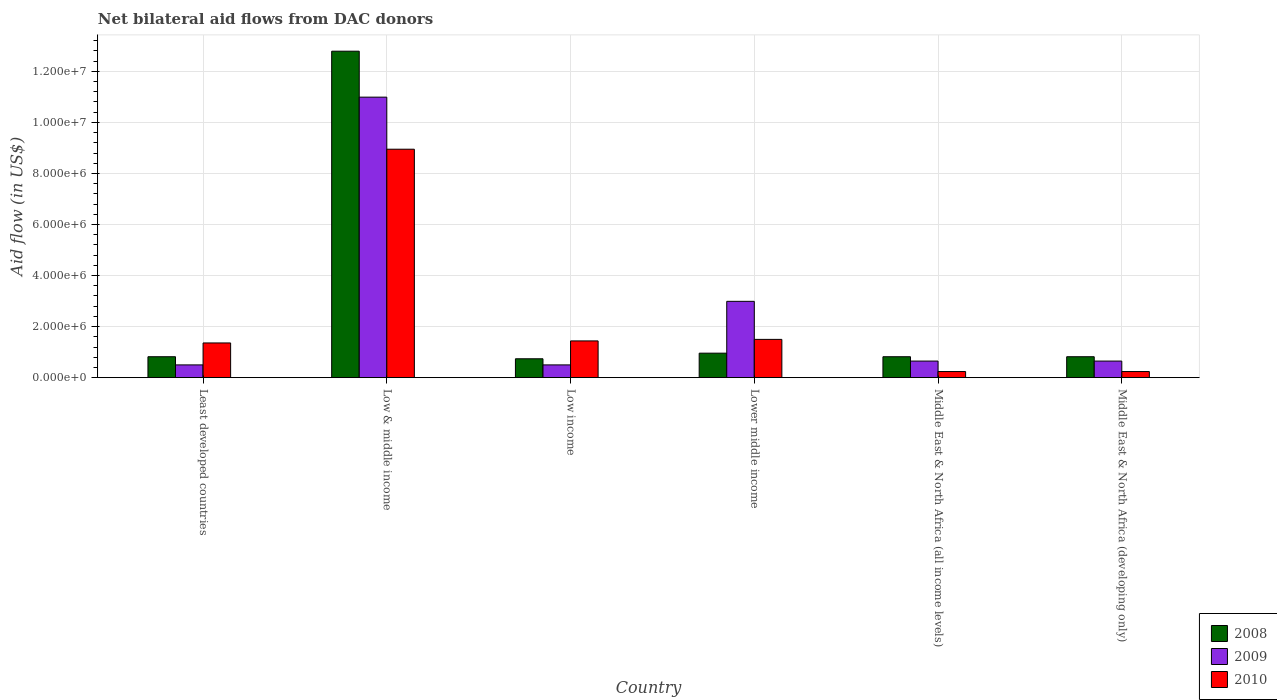How many different coloured bars are there?
Your answer should be compact. 3. How many bars are there on the 5th tick from the left?
Offer a terse response. 3. How many bars are there on the 1st tick from the right?
Your answer should be very brief. 3. What is the label of the 4th group of bars from the left?
Make the answer very short. Lower middle income. What is the net bilateral aid flow in 2008 in Lower middle income?
Provide a succinct answer. 9.60e+05. Across all countries, what is the maximum net bilateral aid flow in 2009?
Give a very brief answer. 1.10e+07. Across all countries, what is the minimum net bilateral aid flow in 2009?
Provide a short and direct response. 5.00e+05. In which country was the net bilateral aid flow in 2010 minimum?
Your response must be concise. Middle East & North Africa (all income levels). What is the total net bilateral aid flow in 2009 in the graph?
Your answer should be compact. 1.63e+07. What is the difference between the net bilateral aid flow in 2010 in Least developed countries and that in Middle East & North Africa (all income levels)?
Ensure brevity in your answer.  1.12e+06. What is the difference between the net bilateral aid flow in 2010 in Low & middle income and the net bilateral aid flow in 2009 in Least developed countries?
Offer a terse response. 8.45e+06. What is the average net bilateral aid flow in 2009 per country?
Ensure brevity in your answer.  2.71e+06. What is the difference between the net bilateral aid flow of/in 2010 and net bilateral aid flow of/in 2008 in Low income?
Give a very brief answer. 7.00e+05. Is the net bilateral aid flow in 2008 in Least developed countries less than that in Middle East & North Africa (all income levels)?
Your answer should be very brief. No. Is the difference between the net bilateral aid flow in 2010 in Least developed countries and Middle East & North Africa (developing only) greater than the difference between the net bilateral aid flow in 2008 in Least developed countries and Middle East & North Africa (developing only)?
Keep it short and to the point. Yes. What is the difference between the highest and the second highest net bilateral aid flow in 2010?
Keep it short and to the point. 7.51e+06. What is the difference between the highest and the lowest net bilateral aid flow in 2008?
Ensure brevity in your answer.  1.20e+07. In how many countries, is the net bilateral aid flow in 2008 greater than the average net bilateral aid flow in 2008 taken over all countries?
Keep it short and to the point. 1. Is the sum of the net bilateral aid flow in 2010 in Lower middle income and Middle East & North Africa (all income levels) greater than the maximum net bilateral aid flow in 2009 across all countries?
Provide a succinct answer. No. What does the 1st bar from the left in Low & middle income represents?
Provide a short and direct response. 2008. How many countries are there in the graph?
Provide a succinct answer. 6. What is the difference between two consecutive major ticks on the Y-axis?
Provide a short and direct response. 2.00e+06. Does the graph contain any zero values?
Keep it short and to the point. No. Where does the legend appear in the graph?
Provide a succinct answer. Bottom right. How are the legend labels stacked?
Your answer should be very brief. Vertical. What is the title of the graph?
Make the answer very short. Net bilateral aid flows from DAC donors. Does "1991" appear as one of the legend labels in the graph?
Make the answer very short. No. What is the label or title of the X-axis?
Provide a short and direct response. Country. What is the label or title of the Y-axis?
Provide a short and direct response. Aid flow (in US$). What is the Aid flow (in US$) of 2008 in Least developed countries?
Ensure brevity in your answer.  8.20e+05. What is the Aid flow (in US$) of 2009 in Least developed countries?
Ensure brevity in your answer.  5.00e+05. What is the Aid flow (in US$) in 2010 in Least developed countries?
Offer a very short reply. 1.36e+06. What is the Aid flow (in US$) of 2008 in Low & middle income?
Make the answer very short. 1.28e+07. What is the Aid flow (in US$) of 2009 in Low & middle income?
Your answer should be very brief. 1.10e+07. What is the Aid flow (in US$) of 2010 in Low & middle income?
Provide a succinct answer. 8.95e+06. What is the Aid flow (in US$) in 2008 in Low income?
Offer a terse response. 7.40e+05. What is the Aid flow (in US$) in 2010 in Low income?
Make the answer very short. 1.44e+06. What is the Aid flow (in US$) of 2008 in Lower middle income?
Your answer should be very brief. 9.60e+05. What is the Aid flow (in US$) in 2009 in Lower middle income?
Provide a succinct answer. 2.99e+06. What is the Aid flow (in US$) of 2010 in Lower middle income?
Offer a terse response. 1.50e+06. What is the Aid flow (in US$) of 2008 in Middle East & North Africa (all income levels)?
Provide a succinct answer. 8.20e+05. What is the Aid flow (in US$) of 2009 in Middle East & North Africa (all income levels)?
Provide a succinct answer. 6.50e+05. What is the Aid flow (in US$) in 2008 in Middle East & North Africa (developing only)?
Give a very brief answer. 8.20e+05. What is the Aid flow (in US$) of 2009 in Middle East & North Africa (developing only)?
Ensure brevity in your answer.  6.50e+05. What is the Aid flow (in US$) of 2010 in Middle East & North Africa (developing only)?
Offer a terse response. 2.40e+05. Across all countries, what is the maximum Aid flow (in US$) in 2008?
Give a very brief answer. 1.28e+07. Across all countries, what is the maximum Aid flow (in US$) of 2009?
Offer a terse response. 1.10e+07. Across all countries, what is the maximum Aid flow (in US$) in 2010?
Ensure brevity in your answer.  8.95e+06. Across all countries, what is the minimum Aid flow (in US$) of 2008?
Provide a short and direct response. 7.40e+05. Across all countries, what is the minimum Aid flow (in US$) of 2009?
Ensure brevity in your answer.  5.00e+05. Across all countries, what is the minimum Aid flow (in US$) in 2010?
Provide a short and direct response. 2.40e+05. What is the total Aid flow (in US$) in 2008 in the graph?
Offer a very short reply. 1.70e+07. What is the total Aid flow (in US$) in 2009 in the graph?
Keep it short and to the point. 1.63e+07. What is the total Aid flow (in US$) of 2010 in the graph?
Your answer should be very brief. 1.37e+07. What is the difference between the Aid flow (in US$) in 2008 in Least developed countries and that in Low & middle income?
Your answer should be very brief. -1.20e+07. What is the difference between the Aid flow (in US$) in 2009 in Least developed countries and that in Low & middle income?
Your answer should be very brief. -1.05e+07. What is the difference between the Aid flow (in US$) of 2010 in Least developed countries and that in Low & middle income?
Your answer should be compact. -7.59e+06. What is the difference between the Aid flow (in US$) in 2008 in Least developed countries and that in Low income?
Ensure brevity in your answer.  8.00e+04. What is the difference between the Aid flow (in US$) in 2010 in Least developed countries and that in Low income?
Offer a very short reply. -8.00e+04. What is the difference between the Aid flow (in US$) in 2009 in Least developed countries and that in Lower middle income?
Offer a very short reply. -2.49e+06. What is the difference between the Aid flow (in US$) of 2010 in Least developed countries and that in Lower middle income?
Offer a very short reply. -1.40e+05. What is the difference between the Aid flow (in US$) of 2009 in Least developed countries and that in Middle East & North Africa (all income levels)?
Provide a succinct answer. -1.50e+05. What is the difference between the Aid flow (in US$) in 2010 in Least developed countries and that in Middle East & North Africa (all income levels)?
Your answer should be very brief. 1.12e+06. What is the difference between the Aid flow (in US$) of 2009 in Least developed countries and that in Middle East & North Africa (developing only)?
Offer a very short reply. -1.50e+05. What is the difference between the Aid flow (in US$) of 2010 in Least developed countries and that in Middle East & North Africa (developing only)?
Offer a very short reply. 1.12e+06. What is the difference between the Aid flow (in US$) of 2008 in Low & middle income and that in Low income?
Offer a very short reply. 1.20e+07. What is the difference between the Aid flow (in US$) in 2009 in Low & middle income and that in Low income?
Your answer should be compact. 1.05e+07. What is the difference between the Aid flow (in US$) in 2010 in Low & middle income and that in Low income?
Make the answer very short. 7.51e+06. What is the difference between the Aid flow (in US$) in 2008 in Low & middle income and that in Lower middle income?
Provide a succinct answer. 1.18e+07. What is the difference between the Aid flow (in US$) of 2009 in Low & middle income and that in Lower middle income?
Make the answer very short. 8.00e+06. What is the difference between the Aid flow (in US$) of 2010 in Low & middle income and that in Lower middle income?
Your answer should be compact. 7.45e+06. What is the difference between the Aid flow (in US$) in 2008 in Low & middle income and that in Middle East & North Africa (all income levels)?
Offer a very short reply. 1.20e+07. What is the difference between the Aid flow (in US$) of 2009 in Low & middle income and that in Middle East & North Africa (all income levels)?
Your answer should be compact. 1.03e+07. What is the difference between the Aid flow (in US$) of 2010 in Low & middle income and that in Middle East & North Africa (all income levels)?
Provide a succinct answer. 8.71e+06. What is the difference between the Aid flow (in US$) in 2008 in Low & middle income and that in Middle East & North Africa (developing only)?
Your answer should be very brief. 1.20e+07. What is the difference between the Aid flow (in US$) of 2009 in Low & middle income and that in Middle East & North Africa (developing only)?
Offer a very short reply. 1.03e+07. What is the difference between the Aid flow (in US$) in 2010 in Low & middle income and that in Middle East & North Africa (developing only)?
Make the answer very short. 8.71e+06. What is the difference between the Aid flow (in US$) in 2009 in Low income and that in Lower middle income?
Provide a succinct answer. -2.49e+06. What is the difference between the Aid flow (in US$) in 2008 in Low income and that in Middle East & North Africa (all income levels)?
Provide a succinct answer. -8.00e+04. What is the difference between the Aid flow (in US$) of 2010 in Low income and that in Middle East & North Africa (all income levels)?
Give a very brief answer. 1.20e+06. What is the difference between the Aid flow (in US$) in 2008 in Low income and that in Middle East & North Africa (developing only)?
Your response must be concise. -8.00e+04. What is the difference between the Aid flow (in US$) in 2010 in Low income and that in Middle East & North Africa (developing only)?
Make the answer very short. 1.20e+06. What is the difference between the Aid flow (in US$) in 2009 in Lower middle income and that in Middle East & North Africa (all income levels)?
Give a very brief answer. 2.34e+06. What is the difference between the Aid flow (in US$) in 2010 in Lower middle income and that in Middle East & North Africa (all income levels)?
Offer a very short reply. 1.26e+06. What is the difference between the Aid flow (in US$) in 2008 in Lower middle income and that in Middle East & North Africa (developing only)?
Your response must be concise. 1.40e+05. What is the difference between the Aid flow (in US$) of 2009 in Lower middle income and that in Middle East & North Africa (developing only)?
Your answer should be compact. 2.34e+06. What is the difference between the Aid flow (in US$) in 2010 in Lower middle income and that in Middle East & North Africa (developing only)?
Provide a short and direct response. 1.26e+06. What is the difference between the Aid flow (in US$) in 2010 in Middle East & North Africa (all income levels) and that in Middle East & North Africa (developing only)?
Your answer should be compact. 0. What is the difference between the Aid flow (in US$) of 2008 in Least developed countries and the Aid flow (in US$) of 2009 in Low & middle income?
Provide a succinct answer. -1.02e+07. What is the difference between the Aid flow (in US$) in 2008 in Least developed countries and the Aid flow (in US$) in 2010 in Low & middle income?
Make the answer very short. -8.13e+06. What is the difference between the Aid flow (in US$) of 2009 in Least developed countries and the Aid flow (in US$) of 2010 in Low & middle income?
Keep it short and to the point. -8.45e+06. What is the difference between the Aid flow (in US$) in 2008 in Least developed countries and the Aid flow (in US$) in 2009 in Low income?
Your answer should be very brief. 3.20e+05. What is the difference between the Aid flow (in US$) of 2008 in Least developed countries and the Aid flow (in US$) of 2010 in Low income?
Your answer should be compact. -6.20e+05. What is the difference between the Aid flow (in US$) in 2009 in Least developed countries and the Aid flow (in US$) in 2010 in Low income?
Keep it short and to the point. -9.40e+05. What is the difference between the Aid flow (in US$) in 2008 in Least developed countries and the Aid flow (in US$) in 2009 in Lower middle income?
Keep it short and to the point. -2.17e+06. What is the difference between the Aid flow (in US$) of 2008 in Least developed countries and the Aid flow (in US$) of 2010 in Lower middle income?
Give a very brief answer. -6.80e+05. What is the difference between the Aid flow (in US$) in 2008 in Least developed countries and the Aid flow (in US$) in 2009 in Middle East & North Africa (all income levels)?
Ensure brevity in your answer.  1.70e+05. What is the difference between the Aid flow (in US$) of 2008 in Least developed countries and the Aid flow (in US$) of 2010 in Middle East & North Africa (all income levels)?
Offer a terse response. 5.80e+05. What is the difference between the Aid flow (in US$) of 2008 in Least developed countries and the Aid flow (in US$) of 2010 in Middle East & North Africa (developing only)?
Offer a terse response. 5.80e+05. What is the difference between the Aid flow (in US$) of 2008 in Low & middle income and the Aid flow (in US$) of 2009 in Low income?
Provide a short and direct response. 1.23e+07. What is the difference between the Aid flow (in US$) in 2008 in Low & middle income and the Aid flow (in US$) in 2010 in Low income?
Provide a short and direct response. 1.14e+07. What is the difference between the Aid flow (in US$) in 2009 in Low & middle income and the Aid flow (in US$) in 2010 in Low income?
Make the answer very short. 9.55e+06. What is the difference between the Aid flow (in US$) of 2008 in Low & middle income and the Aid flow (in US$) of 2009 in Lower middle income?
Give a very brief answer. 9.80e+06. What is the difference between the Aid flow (in US$) of 2008 in Low & middle income and the Aid flow (in US$) of 2010 in Lower middle income?
Give a very brief answer. 1.13e+07. What is the difference between the Aid flow (in US$) of 2009 in Low & middle income and the Aid flow (in US$) of 2010 in Lower middle income?
Provide a succinct answer. 9.49e+06. What is the difference between the Aid flow (in US$) in 2008 in Low & middle income and the Aid flow (in US$) in 2009 in Middle East & North Africa (all income levels)?
Provide a succinct answer. 1.21e+07. What is the difference between the Aid flow (in US$) of 2008 in Low & middle income and the Aid flow (in US$) of 2010 in Middle East & North Africa (all income levels)?
Offer a terse response. 1.26e+07. What is the difference between the Aid flow (in US$) in 2009 in Low & middle income and the Aid flow (in US$) in 2010 in Middle East & North Africa (all income levels)?
Your answer should be very brief. 1.08e+07. What is the difference between the Aid flow (in US$) in 2008 in Low & middle income and the Aid flow (in US$) in 2009 in Middle East & North Africa (developing only)?
Keep it short and to the point. 1.21e+07. What is the difference between the Aid flow (in US$) in 2008 in Low & middle income and the Aid flow (in US$) in 2010 in Middle East & North Africa (developing only)?
Offer a very short reply. 1.26e+07. What is the difference between the Aid flow (in US$) in 2009 in Low & middle income and the Aid flow (in US$) in 2010 in Middle East & North Africa (developing only)?
Give a very brief answer. 1.08e+07. What is the difference between the Aid flow (in US$) of 2008 in Low income and the Aid flow (in US$) of 2009 in Lower middle income?
Provide a succinct answer. -2.25e+06. What is the difference between the Aid flow (in US$) of 2008 in Low income and the Aid flow (in US$) of 2010 in Lower middle income?
Offer a terse response. -7.60e+05. What is the difference between the Aid flow (in US$) of 2009 in Low income and the Aid flow (in US$) of 2010 in Lower middle income?
Give a very brief answer. -1.00e+06. What is the difference between the Aid flow (in US$) of 2008 in Low income and the Aid flow (in US$) of 2009 in Middle East & North Africa (all income levels)?
Your answer should be compact. 9.00e+04. What is the difference between the Aid flow (in US$) in 2008 in Low income and the Aid flow (in US$) in 2010 in Middle East & North Africa (all income levels)?
Your answer should be compact. 5.00e+05. What is the difference between the Aid flow (in US$) in 2008 in Low income and the Aid flow (in US$) in 2010 in Middle East & North Africa (developing only)?
Make the answer very short. 5.00e+05. What is the difference between the Aid flow (in US$) of 2008 in Lower middle income and the Aid flow (in US$) of 2009 in Middle East & North Africa (all income levels)?
Provide a succinct answer. 3.10e+05. What is the difference between the Aid flow (in US$) in 2008 in Lower middle income and the Aid flow (in US$) in 2010 in Middle East & North Africa (all income levels)?
Provide a short and direct response. 7.20e+05. What is the difference between the Aid flow (in US$) of 2009 in Lower middle income and the Aid flow (in US$) of 2010 in Middle East & North Africa (all income levels)?
Offer a very short reply. 2.75e+06. What is the difference between the Aid flow (in US$) of 2008 in Lower middle income and the Aid flow (in US$) of 2010 in Middle East & North Africa (developing only)?
Offer a terse response. 7.20e+05. What is the difference between the Aid flow (in US$) of 2009 in Lower middle income and the Aid flow (in US$) of 2010 in Middle East & North Africa (developing only)?
Your answer should be compact. 2.75e+06. What is the difference between the Aid flow (in US$) of 2008 in Middle East & North Africa (all income levels) and the Aid flow (in US$) of 2010 in Middle East & North Africa (developing only)?
Provide a short and direct response. 5.80e+05. What is the difference between the Aid flow (in US$) in 2009 in Middle East & North Africa (all income levels) and the Aid flow (in US$) in 2010 in Middle East & North Africa (developing only)?
Ensure brevity in your answer.  4.10e+05. What is the average Aid flow (in US$) of 2008 per country?
Your answer should be very brief. 2.82e+06. What is the average Aid flow (in US$) in 2009 per country?
Your answer should be very brief. 2.71e+06. What is the average Aid flow (in US$) of 2010 per country?
Your answer should be very brief. 2.29e+06. What is the difference between the Aid flow (in US$) in 2008 and Aid flow (in US$) in 2009 in Least developed countries?
Keep it short and to the point. 3.20e+05. What is the difference between the Aid flow (in US$) of 2008 and Aid flow (in US$) of 2010 in Least developed countries?
Your answer should be compact. -5.40e+05. What is the difference between the Aid flow (in US$) in 2009 and Aid flow (in US$) in 2010 in Least developed countries?
Your answer should be very brief. -8.60e+05. What is the difference between the Aid flow (in US$) of 2008 and Aid flow (in US$) of 2009 in Low & middle income?
Give a very brief answer. 1.80e+06. What is the difference between the Aid flow (in US$) of 2008 and Aid flow (in US$) of 2010 in Low & middle income?
Make the answer very short. 3.84e+06. What is the difference between the Aid flow (in US$) of 2009 and Aid flow (in US$) of 2010 in Low & middle income?
Provide a succinct answer. 2.04e+06. What is the difference between the Aid flow (in US$) of 2008 and Aid flow (in US$) of 2009 in Low income?
Your answer should be very brief. 2.40e+05. What is the difference between the Aid flow (in US$) of 2008 and Aid flow (in US$) of 2010 in Low income?
Provide a succinct answer. -7.00e+05. What is the difference between the Aid flow (in US$) in 2009 and Aid flow (in US$) in 2010 in Low income?
Your answer should be very brief. -9.40e+05. What is the difference between the Aid flow (in US$) in 2008 and Aid flow (in US$) in 2009 in Lower middle income?
Your answer should be compact. -2.03e+06. What is the difference between the Aid flow (in US$) of 2008 and Aid flow (in US$) of 2010 in Lower middle income?
Offer a very short reply. -5.40e+05. What is the difference between the Aid flow (in US$) of 2009 and Aid flow (in US$) of 2010 in Lower middle income?
Provide a short and direct response. 1.49e+06. What is the difference between the Aid flow (in US$) of 2008 and Aid flow (in US$) of 2010 in Middle East & North Africa (all income levels)?
Ensure brevity in your answer.  5.80e+05. What is the difference between the Aid flow (in US$) in 2009 and Aid flow (in US$) in 2010 in Middle East & North Africa (all income levels)?
Make the answer very short. 4.10e+05. What is the difference between the Aid flow (in US$) in 2008 and Aid flow (in US$) in 2009 in Middle East & North Africa (developing only)?
Your answer should be compact. 1.70e+05. What is the difference between the Aid flow (in US$) in 2008 and Aid flow (in US$) in 2010 in Middle East & North Africa (developing only)?
Offer a terse response. 5.80e+05. What is the ratio of the Aid flow (in US$) of 2008 in Least developed countries to that in Low & middle income?
Offer a very short reply. 0.06. What is the ratio of the Aid flow (in US$) in 2009 in Least developed countries to that in Low & middle income?
Offer a very short reply. 0.05. What is the ratio of the Aid flow (in US$) of 2010 in Least developed countries to that in Low & middle income?
Ensure brevity in your answer.  0.15. What is the ratio of the Aid flow (in US$) of 2008 in Least developed countries to that in Low income?
Offer a terse response. 1.11. What is the ratio of the Aid flow (in US$) of 2010 in Least developed countries to that in Low income?
Your response must be concise. 0.94. What is the ratio of the Aid flow (in US$) of 2008 in Least developed countries to that in Lower middle income?
Your response must be concise. 0.85. What is the ratio of the Aid flow (in US$) in 2009 in Least developed countries to that in Lower middle income?
Offer a terse response. 0.17. What is the ratio of the Aid flow (in US$) in 2010 in Least developed countries to that in Lower middle income?
Ensure brevity in your answer.  0.91. What is the ratio of the Aid flow (in US$) in 2009 in Least developed countries to that in Middle East & North Africa (all income levels)?
Offer a terse response. 0.77. What is the ratio of the Aid flow (in US$) in 2010 in Least developed countries to that in Middle East & North Africa (all income levels)?
Offer a terse response. 5.67. What is the ratio of the Aid flow (in US$) of 2009 in Least developed countries to that in Middle East & North Africa (developing only)?
Give a very brief answer. 0.77. What is the ratio of the Aid flow (in US$) in 2010 in Least developed countries to that in Middle East & North Africa (developing only)?
Your response must be concise. 5.67. What is the ratio of the Aid flow (in US$) of 2008 in Low & middle income to that in Low income?
Provide a succinct answer. 17.28. What is the ratio of the Aid flow (in US$) of 2009 in Low & middle income to that in Low income?
Provide a succinct answer. 21.98. What is the ratio of the Aid flow (in US$) of 2010 in Low & middle income to that in Low income?
Give a very brief answer. 6.22. What is the ratio of the Aid flow (in US$) of 2008 in Low & middle income to that in Lower middle income?
Provide a short and direct response. 13.32. What is the ratio of the Aid flow (in US$) in 2009 in Low & middle income to that in Lower middle income?
Offer a very short reply. 3.68. What is the ratio of the Aid flow (in US$) in 2010 in Low & middle income to that in Lower middle income?
Ensure brevity in your answer.  5.97. What is the ratio of the Aid flow (in US$) of 2008 in Low & middle income to that in Middle East & North Africa (all income levels)?
Provide a succinct answer. 15.6. What is the ratio of the Aid flow (in US$) in 2009 in Low & middle income to that in Middle East & North Africa (all income levels)?
Provide a succinct answer. 16.91. What is the ratio of the Aid flow (in US$) in 2010 in Low & middle income to that in Middle East & North Africa (all income levels)?
Keep it short and to the point. 37.29. What is the ratio of the Aid flow (in US$) in 2008 in Low & middle income to that in Middle East & North Africa (developing only)?
Provide a short and direct response. 15.6. What is the ratio of the Aid flow (in US$) of 2009 in Low & middle income to that in Middle East & North Africa (developing only)?
Offer a terse response. 16.91. What is the ratio of the Aid flow (in US$) in 2010 in Low & middle income to that in Middle East & North Africa (developing only)?
Keep it short and to the point. 37.29. What is the ratio of the Aid flow (in US$) in 2008 in Low income to that in Lower middle income?
Offer a terse response. 0.77. What is the ratio of the Aid flow (in US$) in 2009 in Low income to that in Lower middle income?
Offer a very short reply. 0.17. What is the ratio of the Aid flow (in US$) in 2010 in Low income to that in Lower middle income?
Ensure brevity in your answer.  0.96. What is the ratio of the Aid flow (in US$) in 2008 in Low income to that in Middle East & North Africa (all income levels)?
Ensure brevity in your answer.  0.9. What is the ratio of the Aid flow (in US$) of 2009 in Low income to that in Middle East & North Africa (all income levels)?
Offer a very short reply. 0.77. What is the ratio of the Aid flow (in US$) of 2010 in Low income to that in Middle East & North Africa (all income levels)?
Give a very brief answer. 6. What is the ratio of the Aid flow (in US$) in 2008 in Low income to that in Middle East & North Africa (developing only)?
Give a very brief answer. 0.9. What is the ratio of the Aid flow (in US$) in 2009 in Low income to that in Middle East & North Africa (developing only)?
Keep it short and to the point. 0.77. What is the ratio of the Aid flow (in US$) of 2010 in Low income to that in Middle East & North Africa (developing only)?
Your response must be concise. 6. What is the ratio of the Aid flow (in US$) of 2008 in Lower middle income to that in Middle East & North Africa (all income levels)?
Your answer should be compact. 1.17. What is the ratio of the Aid flow (in US$) of 2009 in Lower middle income to that in Middle East & North Africa (all income levels)?
Keep it short and to the point. 4.6. What is the ratio of the Aid flow (in US$) in 2010 in Lower middle income to that in Middle East & North Africa (all income levels)?
Make the answer very short. 6.25. What is the ratio of the Aid flow (in US$) in 2008 in Lower middle income to that in Middle East & North Africa (developing only)?
Your answer should be very brief. 1.17. What is the ratio of the Aid flow (in US$) in 2010 in Lower middle income to that in Middle East & North Africa (developing only)?
Give a very brief answer. 6.25. What is the ratio of the Aid flow (in US$) in 2008 in Middle East & North Africa (all income levels) to that in Middle East & North Africa (developing only)?
Provide a short and direct response. 1. What is the ratio of the Aid flow (in US$) in 2009 in Middle East & North Africa (all income levels) to that in Middle East & North Africa (developing only)?
Make the answer very short. 1. What is the difference between the highest and the second highest Aid flow (in US$) of 2008?
Provide a succinct answer. 1.18e+07. What is the difference between the highest and the second highest Aid flow (in US$) in 2009?
Offer a terse response. 8.00e+06. What is the difference between the highest and the second highest Aid flow (in US$) in 2010?
Ensure brevity in your answer.  7.45e+06. What is the difference between the highest and the lowest Aid flow (in US$) of 2008?
Your response must be concise. 1.20e+07. What is the difference between the highest and the lowest Aid flow (in US$) of 2009?
Offer a terse response. 1.05e+07. What is the difference between the highest and the lowest Aid flow (in US$) in 2010?
Provide a short and direct response. 8.71e+06. 